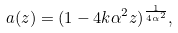<formula> <loc_0><loc_0><loc_500><loc_500>a ( z ) = ( 1 - 4 k \alpha ^ { 2 } z ) ^ { \frac { 1 } { 4 \alpha ^ { 2 } } } ,</formula> 